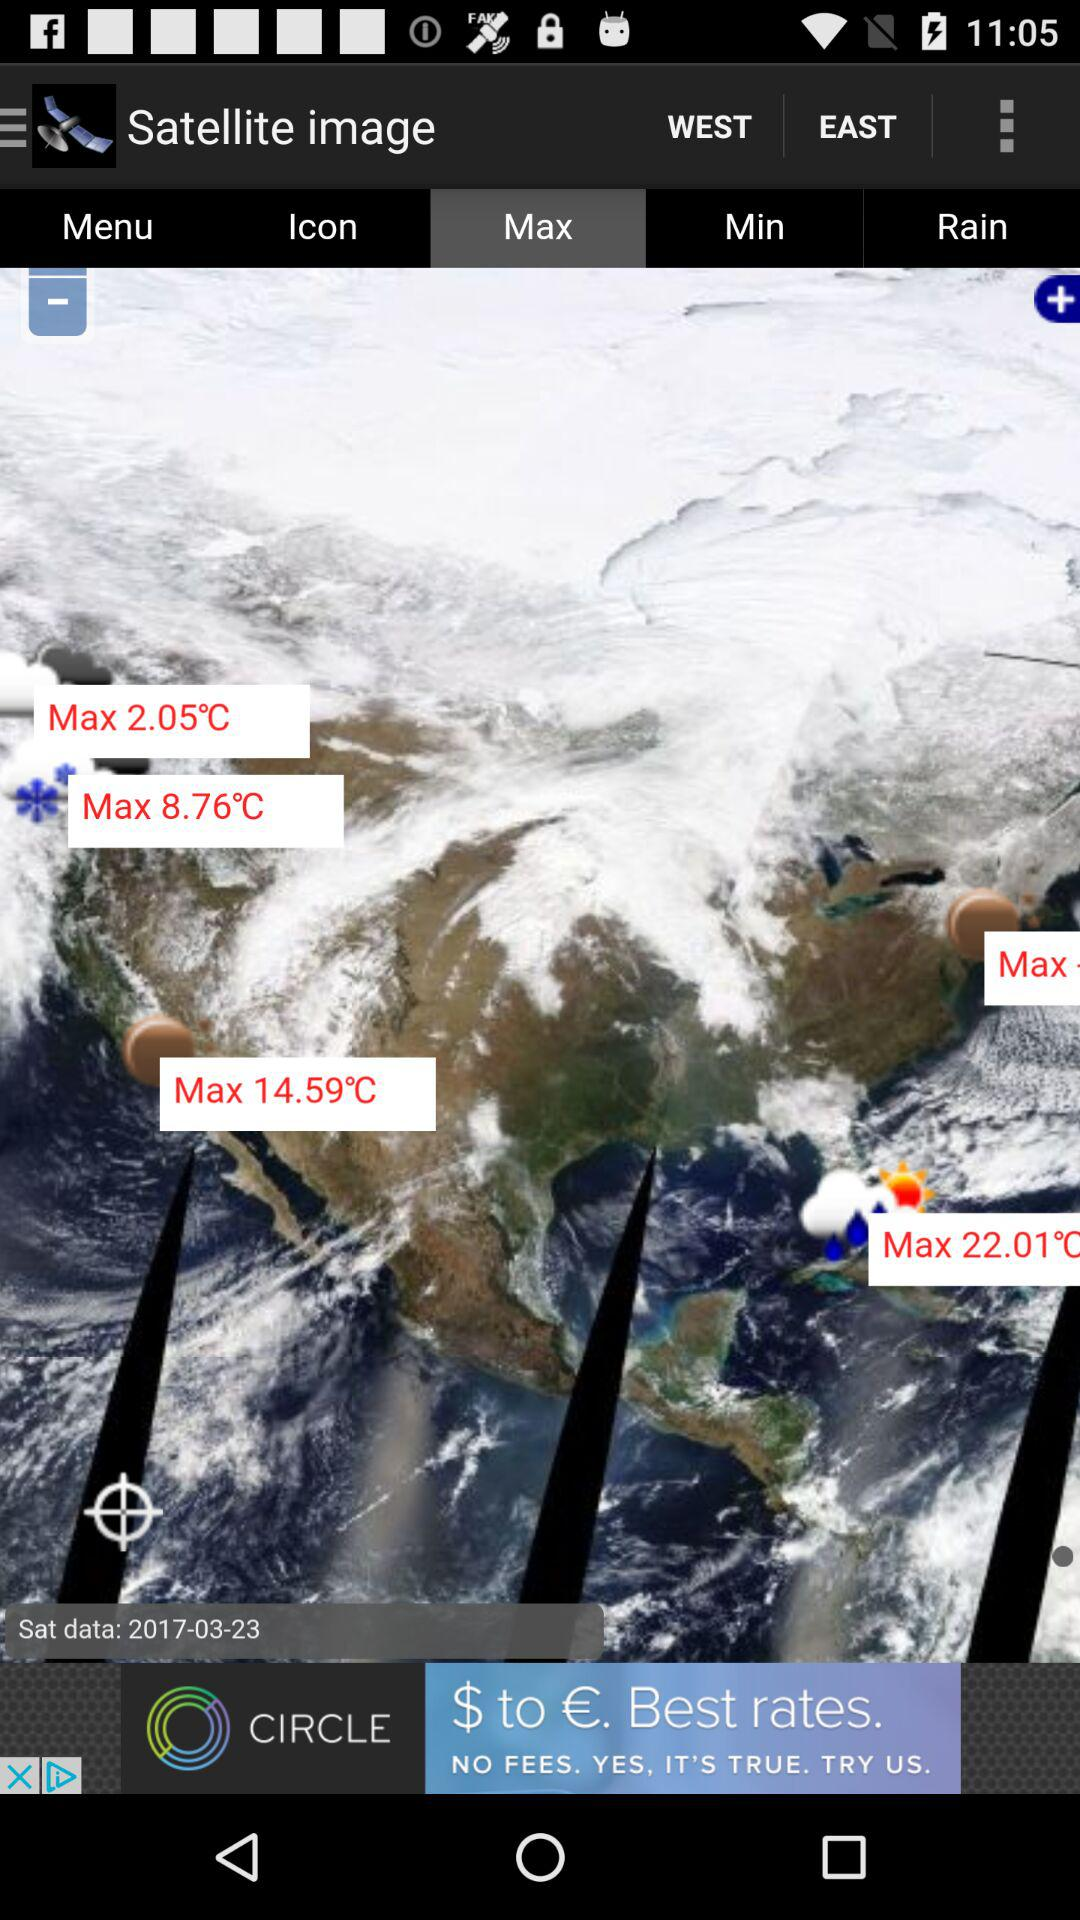Which tab is selected? The selected tab is "Max". 